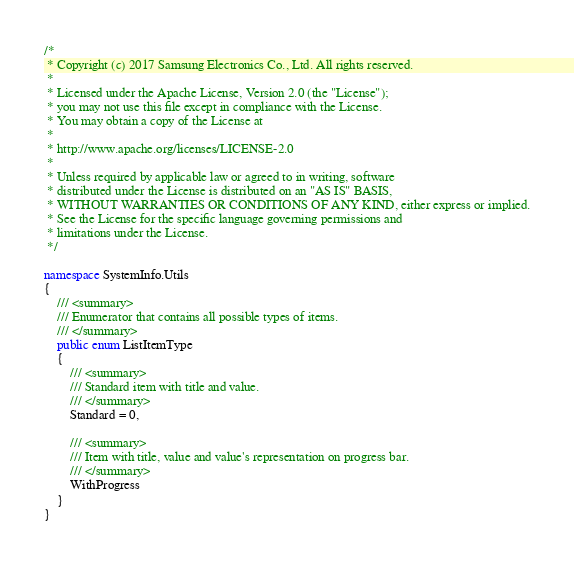Convert code to text. <code><loc_0><loc_0><loc_500><loc_500><_C#_>/*
 * Copyright (c) 2017 Samsung Electronics Co., Ltd. All rights reserved.
 *
 * Licensed under the Apache License, Version 2.0 (the "License");
 * you may not use this file except in compliance with the License.
 * You may obtain a copy of the License at
 *
 * http://www.apache.org/licenses/LICENSE-2.0
 *
 * Unless required by applicable law or agreed to in writing, software
 * distributed under the License is distributed on an "AS IS" BASIS,
 * WITHOUT WARRANTIES OR CONDITIONS OF ANY KIND, either express or implied.
 * See the License for the specific language governing permissions and
 * limitations under the License.
 */

namespace SystemInfo.Utils
{
    /// <summary>
    /// Enumerator that contains all possible types of items.
    /// </summary>
    public enum ListItemType
    {
        /// <summary>
        /// Standard item with title and value.
        /// </summary>
        Standard = 0,

        /// <summary>
        /// Item with title, value and value's representation on progress bar.
        /// </summary>
        WithProgress
    }
}</code> 